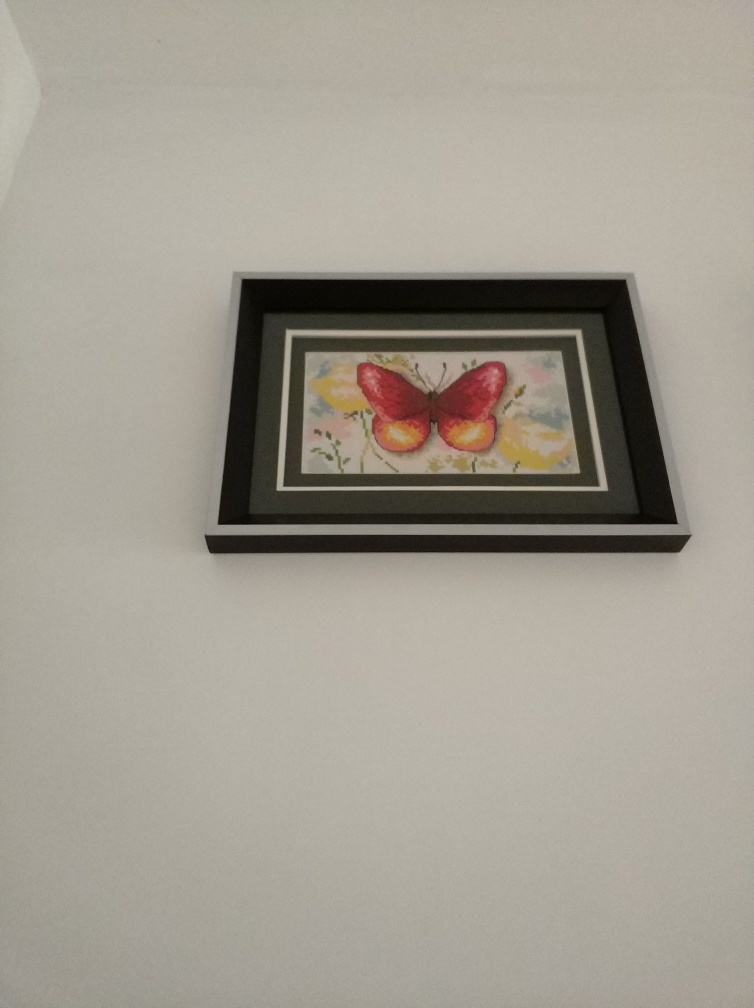Is the color of the image decent? The image exhibits a palette with a soft, pastel background, highlighting the vividly colored red and yellow butterfly in the center. The frame's color complements the artwork's gentle tones while adding contrast, resulting in a visually harmonious presentation. 